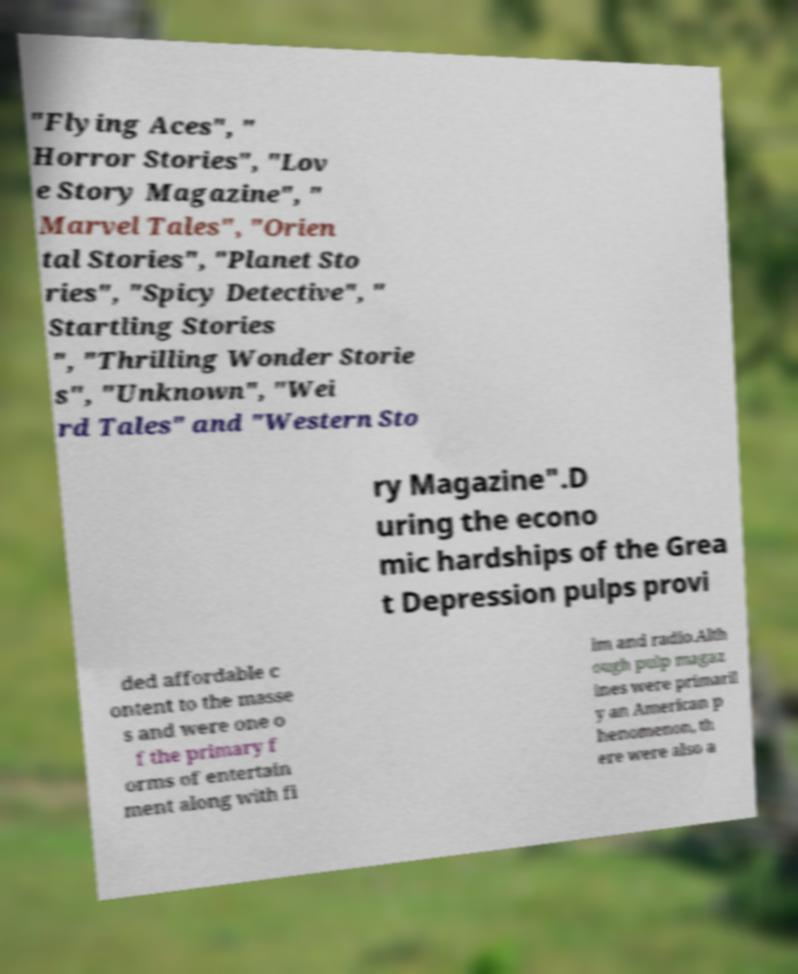Can you read and provide the text displayed in the image?This photo seems to have some interesting text. Can you extract and type it out for me? "Flying Aces", " Horror Stories", "Lov e Story Magazine", " Marvel Tales", "Orien tal Stories", "Planet Sto ries", "Spicy Detective", " Startling Stories ", "Thrilling Wonder Storie s", "Unknown", "Wei rd Tales" and "Western Sto ry Magazine".D uring the econo mic hardships of the Grea t Depression pulps provi ded affordable c ontent to the masse s and were one o f the primary f orms of entertain ment along with fi lm and radio.Alth ough pulp magaz ines were primaril y an American p henomenon, th ere were also a 